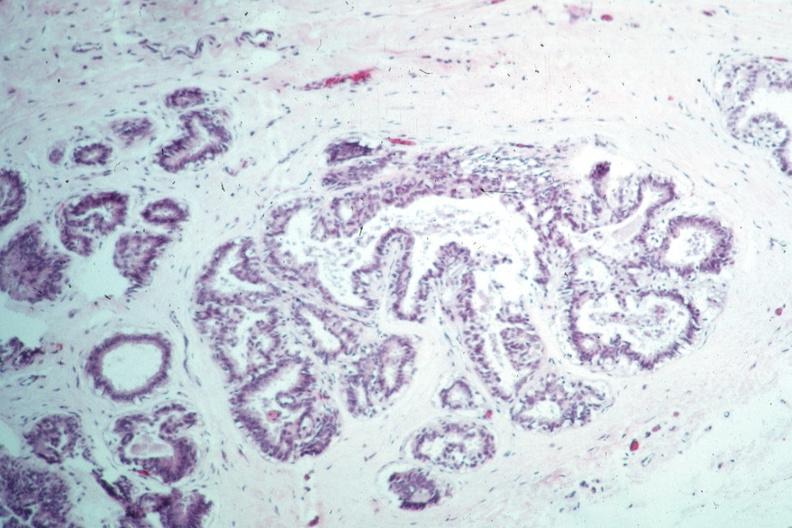does retroperitoneal liposarcoma appear benign?
Answer the question using a single word or phrase. No 